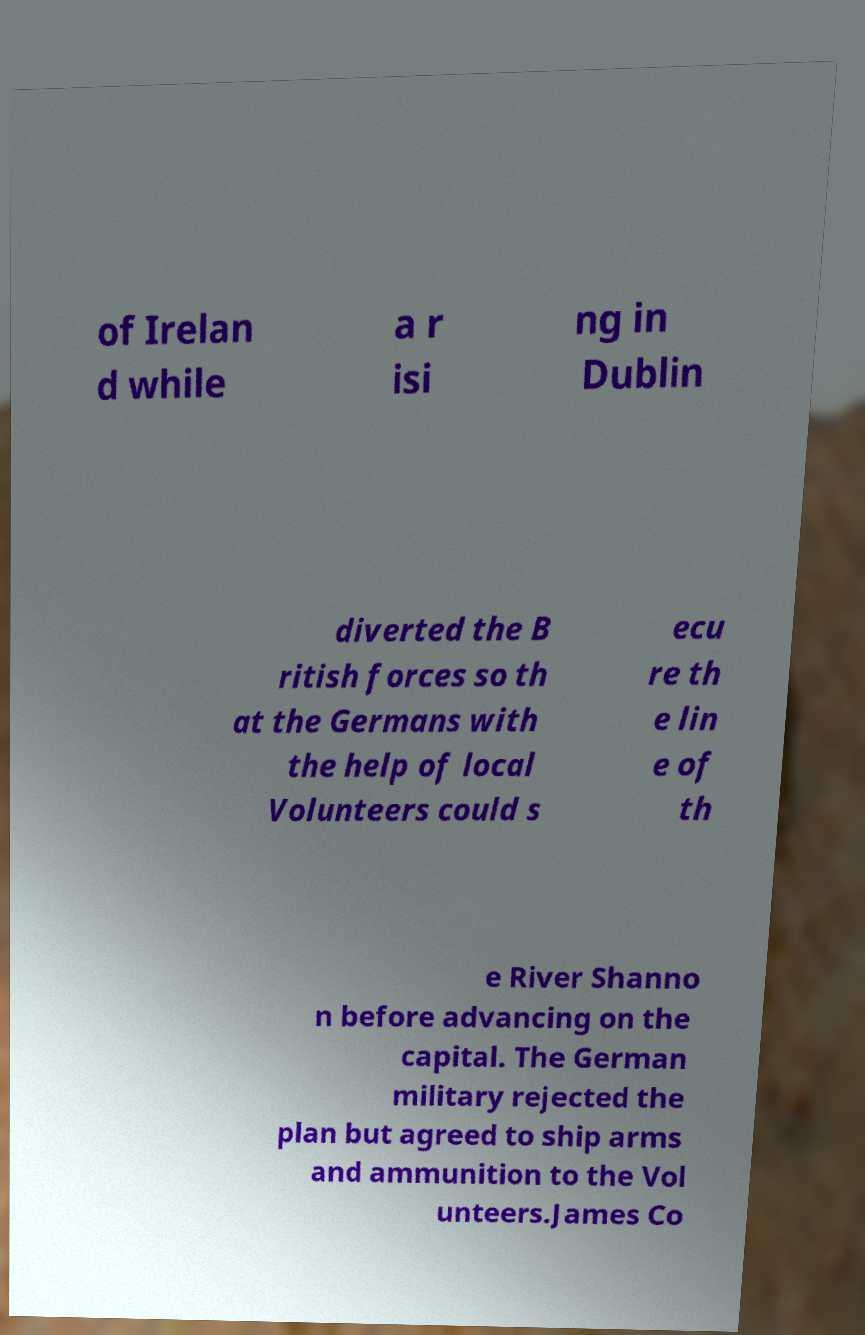Can you read and provide the text displayed in the image?This photo seems to have some interesting text. Can you extract and type it out for me? of Irelan d while a r isi ng in Dublin diverted the B ritish forces so th at the Germans with the help of local Volunteers could s ecu re th e lin e of th e River Shanno n before advancing on the capital. The German military rejected the plan but agreed to ship arms and ammunition to the Vol unteers.James Co 